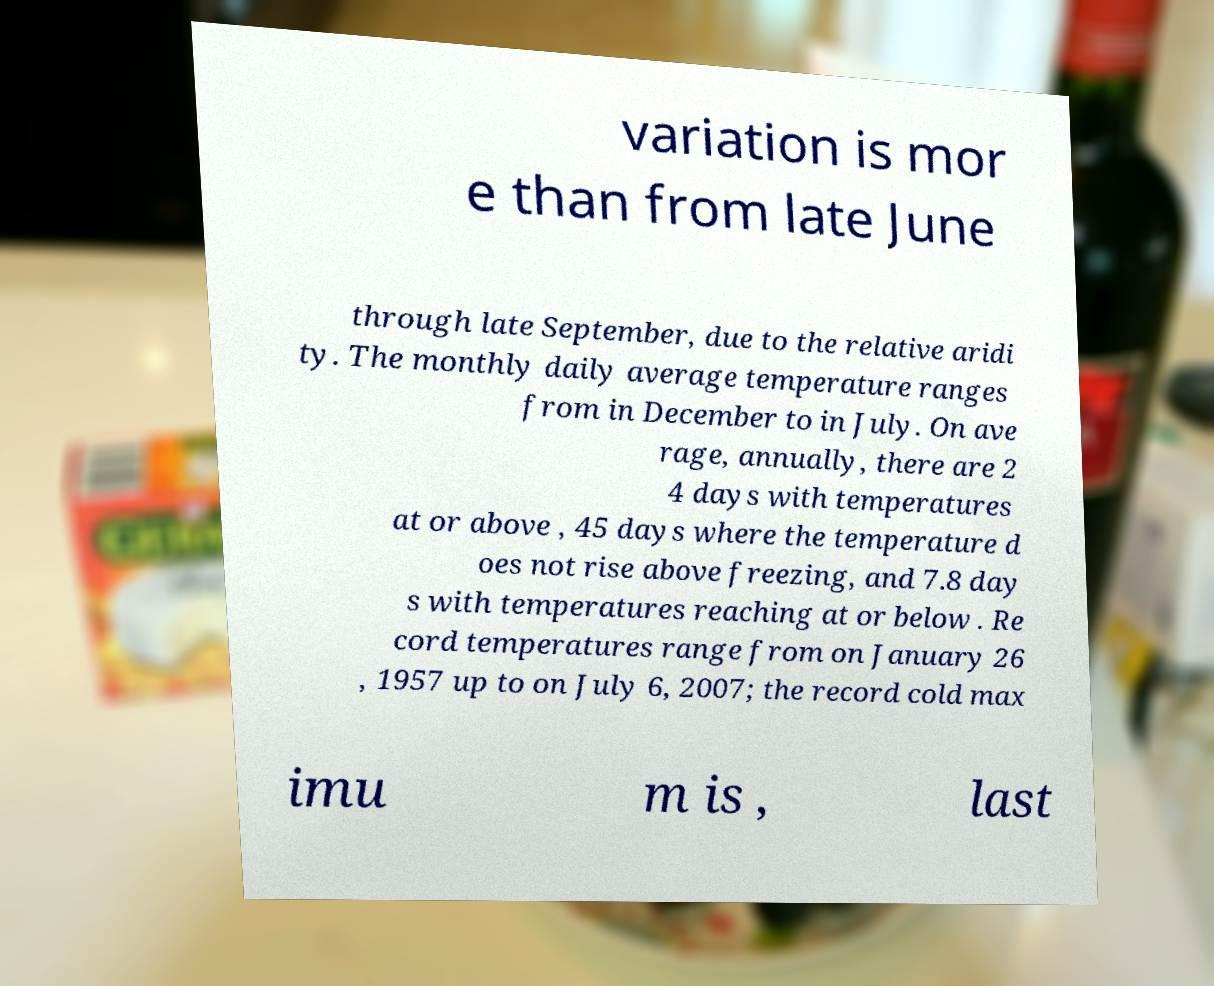For documentation purposes, I need the text within this image transcribed. Could you provide that? variation is mor e than from late June through late September, due to the relative aridi ty. The monthly daily average temperature ranges from in December to in July. On ave rage, annually, there are 2 4 days with temperatures at or above , 45 days where the temperature d oes not rise above freezing, and 7.8 day s with temperatures reaching at or below . Re cord temperatures range from on January 26 , 1957 up to on July 6, 2007; the record cold max imu m is , last 